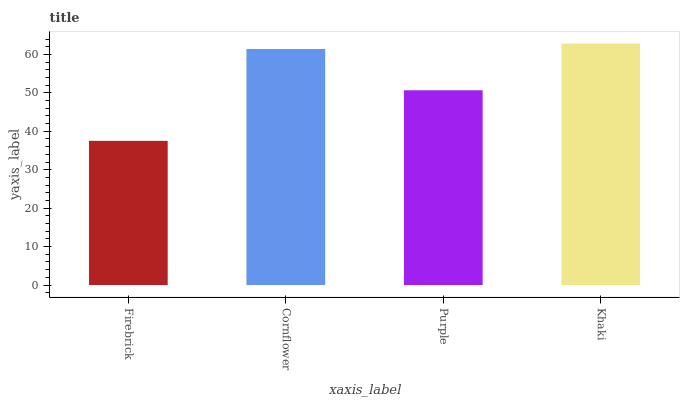Is Firebrick the minimum?
Answer yes or no. Yes. Is Khaki the maximum?
Answer yes or no. Yes. Is Cornflower the minimum?
Answer yes or no. No. Is Cornflower the maximum?
Answer yes or no. No. Is Cornflower greater than Firebrick?
Answer yes or no. Yes. Is Firebrick less than Cornflower?
Answer yes or no. Yes. Is Firebrick greater than Cornflower?
Answer yes or no. No. Is Cornflower less than Firebrick?
Answer yes or no. No. Is Cornflower the high median?
Answer yes or no. Yes. Is Purple the low median?
Answer yes or no. Yes. Is Firebrick the high median?
Answer yes or no. No. Is Khaki the low median?
Answer yes or no. No. 